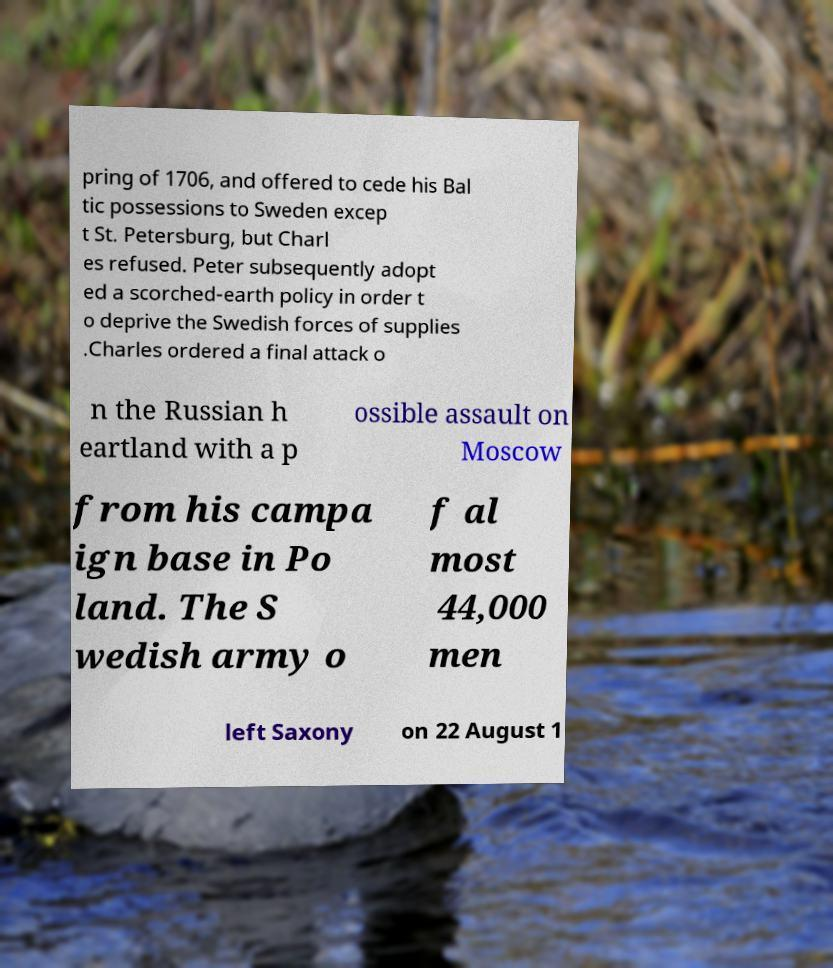Please read and relay the text visible in this image. What does it say? pring of 1706, and offered to cede his Bal tic possessions to Sweden excep t St. Petersburg, but Charl es refused. Peter subsequently adopt ed a scorched-earth policy in order t o deprive the Swedish forces of supplies .Charles ordered a final attack o n the Russian h eartland with a p ossible assault on Moscow from his campa ign base in Po land. The S wedish army o f al most 44,000 men left Saxony on 22 August 1 